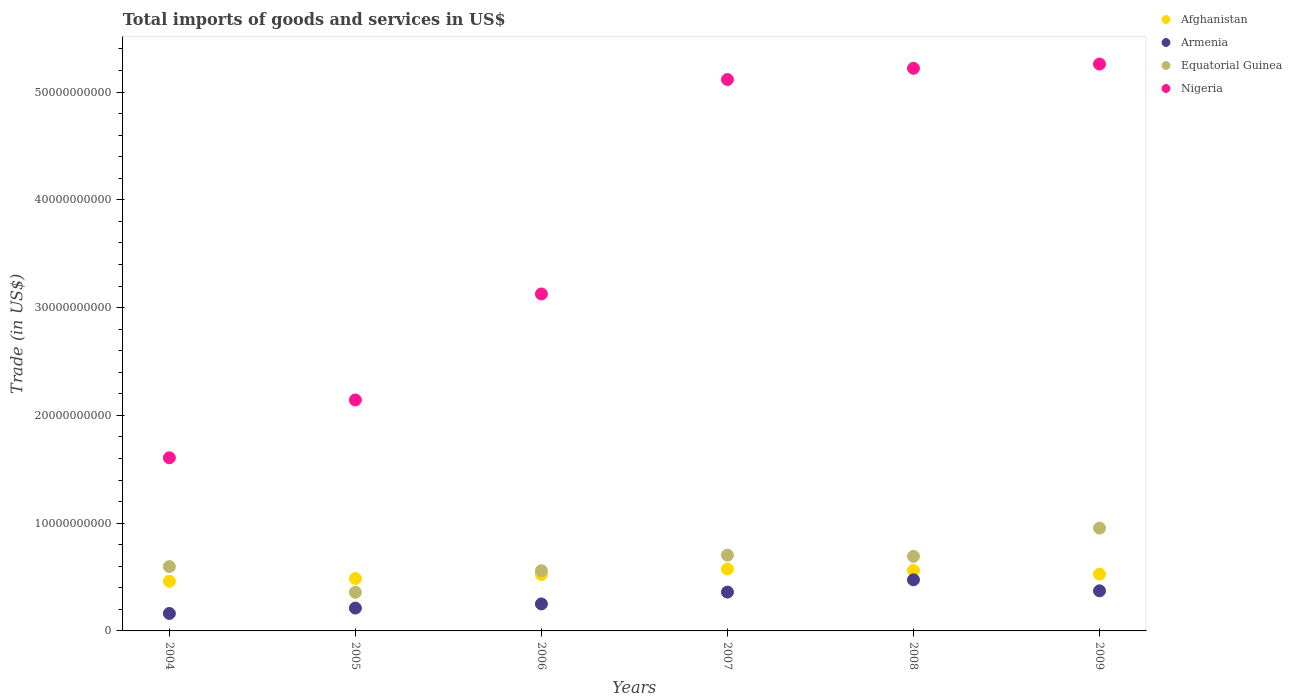What is the total imports of goods and services in Nigeria in 2004?
Make the answer very short. 1.61e+1. Across all years, what is the maximum total imports of goods and services in Armenia?
Provide a short and direct response. 4.74e+09. Across all years, what is the minimum total imports of goods and services in Equatorial Guinea?
Your response must be concise. 3.58e+09. In which year was the total imports of goods and services in Nigeria maximum?
Your answer should be compact. 2009. In which year was the total imports of goods and services in Afghanistan minimum?
Offer a very short reply. 2004. What is the total total imports of goods and services in Equatorial Guinea in the graph?
Your answer should be compact. 3.86e+1. What is the difference between the total imports of goods and services in Afghanistan in 2004 and that in 2007?
Your response must be concise. -1.14e+09. What is the difference between the total imports of goods and services in Equatorial Guinea in 2004 and the total imports of goods and services in Armenia in 2009?
Provide a succinct answer. 2.25e+09. What is the average total imports of goods and services in Armenia per year?
Ensure brevity in your answer.  3.05e+09. In the year 2005, what is the difference between the total imports of goods and services in Afghanistan and total imports of goods and services in Nigeria?
Provide a succinct answer. -1.66e+1. In how many years, is the total imports of goods and services in Nigeria greater than 18000000000 US$?
Your answer should be compact. 5. What is the ratio of the total imports of goods and services in Nigeria in 2006 to that in 2009?
Your answer should be very brief. 0.59. Is the difference between the total imports of goods and services in Afghanistan in 2007 and 2009 greater than the difference between the total imports of goods and services in Nigeria in 2007 and 2009?
Provide a succinct answer. Yes. What is the difference between the highest and the second highest total imports of goods and services in Afghanistan?
Offer a very short reply. 1.32e+08. What is the difference between the highest and the lowest total imports of goods and services in Nigeria?
Make the answer very short. 3.65e+1. In how many years, is the total imports of goods and services in Equatorial Guinea greater than the average total imports of goods and services in Equatorial Guinea taken over all years?
Keep it short and to the point. 3. Is it the case that in every year, the sum of the total imports of goods and services in Afghanistan and total imports of goods and services in Armenia  is greater than the sum of total imports of goods and services in Nigeria and total imports of goods and services in Equatorial Guinea?
Provide a succinct answer. No. Is it the case that in every year, the sum of the total imports of goods and services in Equatorial Guinea and total imports of goods and services in Nigeria  is greater than the total imports of goods and services in Afghanistan?
Keep it short and to the point. Yes. Is the total imports of goods and services in Equatorial Guinea strictly greater than the total imports of goods and services in Nigeria over the years?
Provide a short and direct response. No. Is the total imports of goods and services in Afghanistan strictly less than the total imports of goods and services in Nigeria over the years?
Keep it short and to the point. Yes. How many dotlines are there?
Provide a short and direct response. 4. Where does the legend appear in the graph?
Give a very brief answer. Top right. How are the legend labels stacked?
Give a very brief answer. Vertical. What is the title of the graph?
Your response must be concise. Total imports of goods and services in US$. Does "World" appear as one of the legend labels in the graph?
Offer a terse response. No. What is the label or title of the Y-axis?
Ensure brevity in your answer.  Trade (in US$). What is the Trade (in US$) in Afghanistan in 2004?
Your answer should be very brief. 4.61e+09. What is the Trade (in US$) in Armenia in 2004?
Give a very brief answer. 1.62e+09. What is the Trade (in US$) of Equatorial Guinea in 2004?
Give a very brief answer. 5.97e+09. What is the Trade (in US$) in Nigeria in 2004?
Give a very brief answer. 1.61e+1. What is the Trade (in US$) in Afghanistan in 2005?
Offer a very short reply. 4.86e+09. What is the Trade (in US$) in Armenia in 2005?
Your answer should be compact. 2.12e+09. What is the Trade (in US$) in Equatorial Guinea in 2005?
Your response must be concise. 3.58e+09. What is the Trade (in US$) of Nigeria in 2005?
Keep it short and to the point. 2.14e+1. What is the Trade (in US$) of Afghanistan in 2006?
Offer a terse response. 5.23e+09. What is the Trade (in US$) of Armenia in 2006?
Offer a very short reply. 2.51e+09. What is the Trade (in US$) of Equatorial Guinea in 2006?
Your response must be concise. 5.58e+09. What is the Trade (in US$) in Nigeria in 2006?
Offer a very short reply. 3.13e+1. What is the Trade (in US$) in Afghanistan in 2007?
Offer a terse response. 5.74e+09. What is the Trade (in US$) in Armenia in 2007?
Offer a very short reply. 3.60e+09. What is the Trade (in US$) in Equatorial Guinea in 2007?
Your response must be concise. 7.03e+09. What is the Trade (in US$) in Nigeria in 2007?
Give a very brief answer. 5.12e+1. What is the Trade (in US$) of Afghanistan in 2008?
Ensure brevity in your answer.  5.61e+09. What is the Trade (in US$) of Armenia in 2008?
Provide a succinct answer. 4.74e+09. What is the Trade (in US$) of Equatorial Guinea in 2008?
Keep it short and to the point. 6.92e+09. What is the Trade (in US$) of Nigeria in 2008?
Your response must be concise. 5.22e+1. What is the Trade (in US$) of Afghanistan in 2009?
Ensure brevity in your answer.  5.27e+09. What is the Trade (in US$) of Armenia in 2009?
Provide a short and direct response. 3.72e+09. What is the Trade (in US$) of Equatorial Guinea in 2009?
Your answer should be compact. 9.54e+09. What is the Trade (in US$) of Nigeria in 2009?
Your response must be concise. 5.26e+1. Across all years, what is the maximum Trade (in US$) of Afghanistan?
Offer a terse response. 5.74e+09. Across all years, what is the maximum Trade (in US$) of Armenia?
Your response must be concise. 4.74e+09. Across all years, what is the maximum Trade (in US$) in Equatorial Guinea?
Offer a terse response. 9.54e+09. Across all years, what is the maximum Trade (in US$) in Nigeria?
Provide a succinct answer. 5.26e+1. Across all years, what is the minimum Trade (in US$) in Afghanistan?
Offer a terse response. 4.61e+09. Across all years, what is the minimum Trade (in US$) of Armenia?
Keep it short and to the point. 1.62e+09. Across all years, what is the minimum Trade (in US$) in Equatorial Guinea?
Your answer should be very brief. 3.58e+09. Across all years, what is the minimum Trade (in US$) in Nigeria?
Provide a succinct answer. 1.61e+1. What is the total Trade (in US$) in Afghanistan in the graph?
Your answer should be compact. 3.13e+1. What is the total Trade (in US$) of Armenia in the graph?
Your answer should be very brief. 1.83e+1. What is the total Trade (in US$) in Equatorial Guinea in the graph?
Your answer should be compact. 3.86e+1. What is the total Trade (in US$) of Nigeria in the graph?
Give a very brief answer. 2.25e+11. What is the difference between the Trade (in US$) in Afghanistan in 2004 and that in 2005?
Your answer should be compact. -2.55e+08. What is the difference between the Trade (in US$) of Armenia in 2004 and that in 2005?
Offer a terse response. -4.98e+08. What is the difference between the Trade (in US$) of Equatorial Guinea in 2004 and that in 2005?
Make the answer very short. 2.39e+09. What is the difference between the Trade (in US$) of Nigeria in 2004 and that in 2005?
Make the answer very short. -5.37e+09. What is the difference between the Trade (in US$) of Afghanistan in 2004 and that in 2006?
Keep it short and to the point. -6.23e+08. What is the difference between the Trade (in US$) in Armenia in 2004 and that in 2006?
Your answer should be compact. -8.86e+08. What is the difference between the Trade (in US$) of Equatorial Guinea in 2004 and that in 2006?
Provide a succinct answer. 3.90e+08. What is the difference between the Trade (in US$) of Nigeria in 2004 and that in 2006?
Your answer should be compact. -1.52e+1. What is the difference between the Trade (in US$) of Afghanistan in 2004 and that in 2007?
Give a very brief answer. -1.14e+09. What is the difference between the Trade (in US$) of Armenia in 2004 and that in 2007?
Provide a short and direct response. -1.98e+09. What is the difference between the Trade (in US$) of Equatorial Guinea in 2004 and that in 2007?
Provide a succinct answer. -1.06e+09. What is the difference between the Trade (in US$) in Nigeria in 2004 and that in 2007?
Give a very brief answer. -3.51e+1. What is the difference between the Trade (in US$) of Afghanistan in 2004 and that in 2008?
Make the answer very short. -1.01e+09. What is the difference between the Trade (in US$) in Armenia in 2004 and that in 2008?
Your answer should be compact. -3.12e+09. What is the difference between the Trade (in US$) in Equatorial Guinea in 2004 and that in 2008?
Provide a succinct answer. -9.47e+08. What is the difference between the Trade (in US$) of Nigeria in 2004 and that in 2008?
Give a very brief answer. -3.61e+1. What is the difference between the Trade (in US$) in Afghanistan in 2004 and that in 2009?
Give a very brief answer. -6.64e+08. What is the difference between the Trade (in US$) in Armenia in 2004 and that in 2009?
Your answer should be very brief. -2.10e+09. What is the difference between the Trade (in US$) in Equatorial Guinea in 2004 and that in 2009?
Provide a succinct answer. -3.57e+09. What is the difference between the Trade (in US$) of Nigeria in 2004 and that in 2009?
Ensure brevity in your answer.  -3.65e+1. What is the difference between the Trade (in US$) in Afghanistan in 2005 and that in 2006?
Offer a very short reply. -3.68e+08. What is the difference between the Trade (in US$) in Armenia in 2005 and that in 2006?
Give a very brief answer. -3.87e+08. What is the difference between the Trade (in US$) in Equatorial Guinea in 2005 and that in 2006?
Provide a short and direct response. -2.00e+09. What is the difference between the Trade (in US$) of Nigeria in 2005 and that in 2006?
Ensure brevity in your answer.  -9.83e+09. What is the difference between the Trade (in US$) in Afghanistan in 2005 and that in 2007?
Give a very brief answer. -8.83e+08. What is the difference between the Trade (in US$) in Armenia in 2005 and that in 2007?
Give a very brief answer. -1.49e+09. What is the difference between the Trade (in US$) of Equatorial Guinea in 2005 and that in 2007?
Make the answer very short. -3.45e+09. What is the difference between the Trade (in US$) of Nigeria in 2005 and that in 2007?
Make the answer very short. -2.97e+1. What is the difference between the Trade (in US$) in Afghanistan in 2005 and that in 2008?
Your answer should be very brief. -7.51e+08. What is the difference between the Trade (in US$) in Armenia in 2005 and that in 2008?
Keep it short and to the point. -2.62e+09. What is the difference between the Trade (in US$) of Equatorial Guinea in 2005 and that in 2008?
Make the answer very short. -3.34e+09. What is the difference between the Trade (in US$) in Nigeria in 2005 and that in 2008?
Offer a terse response. -3.08e+1. What is the difference between the Trade (in US$) in Afghanistan in 2005 and that in 2009?
Make the answer very short. -4.08e+08. What is the difference between the Trade (in US$) in Armenia in 2005 and that in 2009?
Give a very brief answer. -1.60e+09. What is the difference between the Trade (in US$) of Equatorial Guinea in 2005 and that in 2009?
Provide a short and direct response. -5.96e+09. What is the difference between the Trade (in US$) of Nigeria in 2005 and that in 2009?
Offer a terse response. -3.12e+1. What is the difference between the Trade (in US$) in Afghanistan in 2006 and that in 2007?
Your answer should be compact. -5.15e+08. What is the difference between the Trade (in US$) in Armenia in 2006 and that in 2007?
Offer a very short reply. -1.10e+09. What is the difference between the Trade (in US$) of Equatorial Guinea in 2006 and that in 2007?
Offer a terse response. -1.45e+09. What is the difference between the Trade (in US$) in Nigeria in 2006 and that in 2007?
Keep it short and to the point. -1.99e+1. What is the difference between the Trade (in US$) in Afghanistan in 2006 and that in 2008?
Offer a very short reply. -3.84e+08. What is the difference between the Trade (in US$) in Armenia in 2006 and that in 2008?
Your answer should be compact. -2.24e+09. What is the difference between the Trade (in US$) in Equatorial Guinea in 2006 and that in 2008?
Offer a very short reply. -1.34e+09. What is the difference between the Trade (in US$) of Nigeria in 2006 and that in 2008?
Offer a terse response. -2.09e+1. What is the difference between the Trade (in US$) of Afghanistan in 2006 and that in 2009?
Keep it short and to the point. -4.08e+07. What is the difference between the Trade (in US$) in Armenia in 2006 and that in 2009?
Keep it short and to the point. -1.21e+09. What is the difference between the Trade (in US$) in Equatorial Guinea in 2006 and that in 2009?
Provide a short and direct response. -3.96e+09. What is the difference between the Trade (in US$) in Nigeria in 2006 and that in 2009?
Provide a succinct answer. -2.13e+1. What is the difference between the Trade (in US$) of Afghanistan in 2007 and that in 2008?
Your answer should be very brief. 1.32e+08. What is the difference between the Trade (in US$) in Armenia in 2007 and that in 2008?
Keep it short and to the point. -1.14e+09. What is the difference between the Trade (in US$) in Equatorial Guinea in 2007 and that in 2008?
Make the answer very short. 1.16e+08. What is the difference between the Trade (in US$) in Nigeria in 2007 and that in 2008?
Your answer should be very brief. -1.05e+09. What is the difference between the Trade (in US$) in Afghanistan in 2007 and that in 2009?
Keep it short and to the point. 4.74e+08. What is the difference between the Trade (in US$) in Armenia in 2007 and that in 2009?
Provide a succinct answer. -1.15e+08. What is the difference between the Trade (in US$) of Equatorial Guinea in 2007 and that in 2009?
Ensure brevity in your answer.  -2.51e+09. What is the difference between the Trade (in US$) of Nigeria in 2007 and that in 2009?
Give a very brief answer. -1.44e+09. What is the difference between the Trade (in US$) of Afghanistan in 2008 and that in 2009?
Make the answer very short. 3.43e+08. What is the difference between the Trade (in US$) in Armenia in 2008 and that in 2009?
Make the answer very short. 1.02e+09. What is the difference between the Trade (in US$) of Equatorial Guinea in 2008 and that in 2009?
Offer a terse response. -2.62e+09. What is the difference between the Trade (in US$) in Nigeria in 2008 and that in 2009?
Keep it short and to the point. -3.94e+08. What is the difference between the Trade (in US$) of Afghanistan in 2004 and the Trade (in US$) of Armenia in 2005?
Your answer should be very brief. 2.49e+09. What is the difference between the Trade (in US$) of Afghanistan in 2004 and the Trade (in US$) of Equatorial Guinea in 2005?
Provide a short and direct response. 1.02e+09. What is the difference between the Trade (in US$) of Afghanistan in 2004 and the Trade (in US$) of Nigeria in 2005?
Offer a very short reply. -1.68e+1. What is the difference between the Trade (in US$) in Armenia in 2004 and the Trade (in US$) in Equatorial Guinea in 2005?
Ensure brevity in your answer.  -1.96e+09. What is the difference between the Trade (in US$) of Armenia in 2004 and the Trade (in US$) of Nigeria in 2005?
Provide a succinct answer. -1.98e+1. What is the difference between the Trade (in US$) of Equatorial Guinea in 2004 and the Trade (in US$) of Nigeria in 2005?
Provide a succinct answer. -1.55e+1. What is the difference between the Trade (in US$) of Afghanistan in 2004 and the Trade (in US$) of Armenia in 2006?
Keep it short and to the point. 2.10e+09. What is the difference between the Trade (in US$) of Afghanistan in 2004 and the Trade (in US$) of Equatorial Guinea in 2006?
Give a very brief answer. -9.76e+08. What is the difference between the Trade (in US$) in Afghanistan in 2004 and the Trade (in US$) in Nigeria in 2006?
Offer a terse response. -2.67e+1. What is the difference between the Trade (in US$) in Armenia in 2004 and the Trade (in US$) in Equatorial Guinea in 2006?
Offer a terse response. -3.96e+09. What is the difference between the Trade (in US$) of Armenia in 2004 and the Trade (in US$) of Nigeria in 2006?
Your answer should be very brief. -2.96e+1. What is the difference between the Trade (in US$) of Equatorial Guinea in 2004 and the Trade (in US$) of Nigeria in 2006?
Make the answer very short. -2.53e+1. What is the difference between the Trade (in US$) of Afghanistan in 2004 and the Trade (in US$) of Armenia in 2007?
Ensure brevity in your answer.  1.00e+09. What is the difference between the Trade (in US$) in Afghanistan in 2004 and the Trade (in US$) in Equatorial Guinea in 2007?
Ensure brevity in your answer.  -2.43e+09. What is the difference between the Trade (in US$) in Afghanistan in 2004 and the Trade (in US$) in Nigeria in 2007?
Your answer should be compact. -4.66e+1. What is the difference between the Trade (in US$) in Armenia in 2004 and the Trade (in US$) in Equatorial Guinea in 2007?
Give a very brief answer. -5.41e+09. What is the difference between the Trade (in US$) in Armenia in 2004 and the Trade (in US$) in Nigeria in 2007?
Give a very brief answer. -4.95e+1. What is the difference between the Trade (in US$) of Equatorial Guinea in 2004 and the Trade (in US$) of Nigeria in 2007?
Offer a terse response. -4.52e+1. What is the difference between the Trade (in US$) in Afghanistan in 2004 and the Trade (in US$) in Armenia in 2008?
Provide a short and direct response. -1.36e+08. What is the difference between the Trade (in US$) of Afghanistan in 2004 and the Trade (in US$) of Equatorial Guinea in 2008?
Give a very brief answer. -2.31e+09. What is the difference between the Trade (in US$) in Afghanistan in 2004 and the Trade (in US$) in Nigeria in 2008?
Offer a very short reply. -4.76e+1. What is the difference between the Trade (in US$) in Armenia in 2004 and the Trade (in US$) in Equatorial Guinea in 2008?
Your response must be concise. -5.30e+09. What is the difference between the Trade (in US$) in Armenia in 2004 and the Trade (in US$) in Nigeria in 2008?
Provide a succinct answer. -5.06e+1. What is the difference between the Trade (in US$) of Equatorial Guinea in 2004 and the Trade (in US$) of Nigeria in 2008?
Offer a very short reply. -4.62e+1. What is the difference between the Trade (in US$) of Afghanistan in 2004 and the Trade (in US$) of Armenia in 2009?
Provide a succinct answer. 8.87e+08. What is the difference between the Trade (in US$) in Afghanistan in 2004 and the Trade (in US$) in Equatorial Guinea in 2009?
Your response must be concise. -4.93e+09. What is the difference between the Trade (in US$) of Afghanistan in 2004 and the Trade (in US$) of Nigeria in 2009?
Keep it short and to the point. -4.80e+1. What is the difference between the Trade (in US$) of Armenia in 2004 and the Trade (in US$) of Equatorial Guinea in 2009?
Your answer should be very brief. -7.92e+09. What is the difference between the Trade (in US$) of Armenia in 2004 and the Trade (in US$) of Nigeria in 2009?
Keep it short and to the point. -5.10e+1. What is the difference between the Trade (in US$) in Equatorial Guinea in 2004 and the Trade (in US$) in Nigeria in 2009?
Keep it short and to the point. -4.66e+1. What is the difference between the Trade (in US$) in Afghanistan in 2005 and the Trade (in US$) in Armenia in 2006?
Keep it short and to the point. 2.36e+09. What is the difference between the Trade (in US$) in Afghanistan in 2005 and the Trade (in US$) in Equatorial Guinea in 2006?
Your answer should be very brief. -7.20e+08. What is the difference between the Trade (in US$) of Afghanistan in 2005 and the Trade (in US$) of Nigeria in 2006?
Give a very brief answer. -2.64e+1. What is the difference between the Trade (in US$) of Armenia in 2005 and the Trade (in US$) of Equatorial Guinea in 2006?
Offer a terse response. -3.46e+09. What is the difference between the Trade (in US$) in Armenia in 2005 and the Trade (in US$) in Nigeria in 2006?
Your answer should be very brief. -2.91e+1. What is the difference between the Trade (in US$) in Equatorial Guinea in 2005 and the Trade (in US$) in Nigeria in 2006?
Provide a short and direct response. -2.77e+1. What is the difference between the Trade (in US$) of Afghanistan in 2005 and the Trade (in US$) of Armenia in 2007?
Your answer should be compact. 1.26e+09. What is the difference between the Trade (in US$) in Afghanistan in 2005 and the Trade (in US$) in Equatorial Guinea in 2007?
Your answer should be very brief. -2.17e+09. What is the difference between the Trade (in US$) in Afghanistan in 2005 and the Trade (in US$) in Nigeria in 2007?
Offer a terse response. -4.63e+1. What is the difference between the Trade (in US$) in Armenia in 2005 and the Trade (in US$) in Equatorial Guinea in 2007?
Provide a succinct answer. -4.92e+09. What is the difference between the Trade (in US$) of Armenia in 2005 and the Trade (in US$) of Nigeria in 2007?
Ensure brevity in your answer.  -4.90e+1. What is the difference between the Trade (in US$) of Equatorial Guinea in 2005 and the Trade (in US$) of Nigeria in 2007?
Ensure brevity in your answer.  -4.76e+1. What is the difference between the Trade (in US$) of Afghanistan in 2005 and the Trade (in US$) of Armenia in 2008?
Provide a short and direct response. 1.20e+08. What is the difference between the Trade (in US$) of Afghanistan in 2005 and the Trade (in US$) of Equatorial Guinea in 2008?
Give a very brief answer. -2.06e+09. What is the difference between the Trade (in US$) of Afghanistan in 2005 and the Trade (in US$) of Nigeria in 2008?
Your answer should be compact. -4.73e+1. What is the difference between the Trade (in US$) of Armenia in 2005 and the Trade (in US$) of Equatorial Guinea in 2008?
Provide a succinct answer. -4.80e+09. What is the difference between the Trade (in US$) in Armenia in 2005 and the Trade (in US$) in Nigeria in 2008?
Make the answer very short. -5.01e+1. What is the difference between the Trade (in US$) in Equatorial Guinea in 2005 and the Trade (in US$) in Nigeria in 2008?
Offer a terse response. -4.86e+1. What is the difference between the Trade (in US$) in Afghanistan in 2005 and the Trade (in US$) in Armenia in 2009?
Ensure brevity in your answer.  1.14e+09. What is the difference between the Trade (in US$) in Afghanistan in 2005 and the Trade (in US$) in Equatorial Guinea in 2009?
Your answer should be compact. -4.68e+09. What is the difference between the Trade (in US$) in Afghanistan in 2005 and the Trade (in US$) in Nigeria in 2009?
Provide a short and direct response. -4.77e+1. What is the difference between the Trade (in US$) of Armenia in 2005 and the Trade (in US$) of Equatorial Guinea in 2009?
Make the answer very short. -7.42e+09. What is the difference between the Trade (in US$) of Armenia in 2005 and the Trade (in US$) of Nigeria in 2009?
Provide a succinct answer. -5.05e+1. What is the difference between the Trade (in US$) in Equatorial Guinea in 2005 and the Trade (in US$) in Nigeria in 2009?
Give a very brief answer. -4.90e+1. What is the difference between the Trade (in US$) in Afghanistan in 2006 and the Trade (in US$) in Armenia in 2007?
Provide a short and direct response. 1.62e+09. What is the difference between the Trade (in US$) in Afghanistan in 2006 and the Trade (in US$) in Equatorial Guinea in 2007?
Your answer should be compact. -1.81e+09. What is the difference between the Trade (in US$) in Afghanistan in 2006 and the Trade (in US$) in Nigeria in 2007?
Make the answer very short. -4.59e+1. What is the difference between the Trade (in US$) of Armenia in 2006 and the Trade (in US$) of Equatorial Guinea in 2007?
Provide a succinct answer. -4.53e+09. What is the difference between the Trade (in US$) in Armenia in 2006 and the Trade (in US$) in Nigeria in 2007?
Provide a succinct answer. -4.87e+1. What is the difference between the Trade (in US$) in Equatorial Guinea in 2006 and the Trade (in US$) in Nigeria in 2007?
Your response must be concise. -4.56e+1. What is the difference between the Trade (in US$) of Afghanistan in 2006 and the Trade (in US$) of Armenia in 2008?
Make the answer very short. 4.87e+08. What is the difference between the Trade (in US$) of Afghanistan in 2006 and the Trade (in US$) of Equatorial Guinea in 2008?
Make the answer very short. -1.69e+09. What is the difference between the Trade (in US$) in Afghanistan in 2006 and the Trade (in US$) in Nigeria in 2008?
Ensure brevity in your answer.  -4.70e+1. What is the difference between the Trade (in US$) of Armenia in 2006 and the Trade (in US$) of Equatorial Guinea in 2008?
Give a very brief answer. -4.41e+09. What is the difference between the Trade (in US$) in Armenia in 2006 and the Trade (in US$) in Nigeria in 2008?
Keep it short and to the point. -4.97e+1. What is the difference between the Trade (in US$) of Equatorial Guinea in 2006 and the Trade (in US$) of Nigeria in 2008?
Keep it short and to the point. -4.66e+1. What is the difference between the Trade (in US$) of Afghanistan in 2006 and the Trade (in US$) of Armenia in 2009?
Your response must be concise. 1.51e+09. What is the difference between the Trade (in US$) in Afghanistan in 2006 and the Trade (in US$) in Equatorial Guinea in 2009?
Your answer should be very brief. -4.31e+09. What is the difference between the Trade (in US$) of Afghanistan in 2006 and the Trade (in US$) of Nigeria in 2009?
Offer a very short reply. -4.74e+1. What is the difference between the Trade (in US$) in Armenia in 2006 and the Trade (in US$) in Equatorial Guinea in 2009?
Your answer should be compact. -7.03e+09. What is the difference between the Trade (in US$) in Armenia in 2006 and the Trade (in US$) in Nigeria in 2009?
Provide a succinct answer. -5.01e+1. What is the difference between the Trade (in US$) of Equatorial Guinea in 2006 and the Trade (in US$) of Nigeria in 2009?
Keep it short and to the point. -4.70e+1. What is the difference between the Trade (in US$) in Afghanistan in 2007 and the Trade (in US$) in Armenia in 2008?
Offer a terse response. 1.00e+09. What is the difference between the Trade (in US$) of Afghanistan in 2007 and the Trade (in US$) of Equatorial Guinea in 2008?
Your answer should be compact. -1.17e+09. What is the difference between the Trade (in US$) of Afghanistan in 2007 and the Trade (in US$) of Nigeria in 2008?
Ensure brevity in your answer.  -4.65e+1. What is the difference between the Trade (in US$) in Armenia in 2007 and the Trade (in US$) in Equatorial Guinea in 2008?
Your answer should be compact. -3.31e+09. What is the difference between the Trade (in US$) in Armenia in 2007 and the Trade (in US$) in Nigeria in 2008?
Offer a terse response. -4.86e+1. What is the difference between the Trade (in US$) of Equatorial Guinea in 2007 and the Trade (in US$) of Nigeria in 2008?
Provide a short and direct response. -4.52e+1. What is the difference between the Trade (in US$) in Afghanistan in 2007 and the Trade (in US$) in Armenia in 2009?
Offer a very short reply. 2.02e+09. What is the difference between the Trade (in US$) in Afghanistan in 2007 and the Trade (in US$) in Equatorial Guinea in 2009?
Keep it short and to the point. -3.80e+09. What is the difference between the Trade (in US$) of Afghanistan in 2007 and the Trade (in US$) of Nigeria in 2009?
Keep it short and to the point. -4.69e+1. What is the difference between the Trade (in US$) in Armenia in 2007 and the Trade (in US$) in Equatorial Guinea in 2009?
Your response must be concise. -5.94e+09. What is the difference between the Trade (in US$) of Armenia in 2007 and the Trade (in US$) of Nigeria in 2009?
Ensure brevity in your answer.  -4.90e+1. What is the difference between the Trade (in US$) of Equatorial Guinea in 2007 and the Trade (in US$) of Nigeria in 2009?
Provide a succinct answer. -4.56e+1. What is the difference between the Trade (in US$) of Afghanistan in 2008 and the Trade (in US$) of Armenia in 2009?
Offer a very short reply. 1.89e+09. What is the difference between the Trade (in US$) in Afghanistan in 2008 and the Trade (in US$) in Equatorial Guinea in 2009?
Give a very brief answer. -3.93e+09. What is the difference between the Trade (in US$) of Afghanistan in 2008 and the Trade (in US$) of Nigeria in 2009?
Keep it short and to the point. -4.70e+1. What is the difference between the Trade (in US$) in Armenia in 2008 and the Trade (in US$) in Equatorial Guinea in 2009?
Your response must be concise. -4.80e+09. What is the difference between the Trade (in US$) of Armenia in 2008 and the Trade (in US$) of Nigeria in 2009?
Your response must be concise. -4.79e+1. What is the difference between the Trade (in US$) of Equatorial Guinea in 2008 and the Trade (in US$) of Nigeria in 2009?
Offer a terse response. -4.57e+1. What is the average Trade (in US$) in Afghanistan per year?
Make the answer very short. 5.22e+09. What is the average Trade (in US$) of Armenia per year?
Make the answer very short. 3.05e+09. What is the average Trade (in US$) in Equatorial Guinea per year?
Offer a terse response. 6.44e+09. What is the average Trade (in US$) of Nigeria per year?
Provide a succinct answer. 3.75e+1. In the year 2004, what is the difference between the Trade (in US$) of Afghanistan and Trade (in US$) of Armenia?
Provide a short and direct response. 2.99e+09. In the year 2004, what is the difference between the Trade (in US$) in Afghanistan and Trade (in US$) in Equatorial Guinea?
Provide a short and direct response. -1.37e+09. In the year 2004, what is the difference between the Trade (in US$) of Afghanistan and Trade (in US$) of Nigeria?
Provide a succinct answer. -1.15e+1. In the year 2004, what is the difference between the Trade (in US$) of Armenia and Trade (in US$) of Equatorial Guinea?
Offer a very short reply. -4.35e+09. In the year 2004, what is the difference between the Trade (in US$) in Armenia and Trade (in US$) in Nigeria?
Provide a short and direct response. -1.44e+1. In the year 2004, what is the difference between the Trade (in US$) of Equatorial Guinea and Trade (in US$) of Nigeria?
Offer a very short reply. -1.01e+1. In the year 2005, what is the difference between the Trade (in US$) of Afghanistan and Trade (in US$) of Armenia?
Keep it short and to the point. 2.74e+09. In the year 2005, what is the difference between the Trade (in US$) of Afghanistan and Trade (in US$) of Equatorial Guinea?
Provide a short and direct response. 1.28e+09. In the year 2005, what is the difference between the Trade (in US$) of Afghanistan and Trade (in US$) of Nigeria?
Your response must be concise. -1.66e+1. In the year 2005, what is the difference between the Trade (in US$) of Armenia and Trade (in US$) of Equatorial Guinea?
Your answer should be very brief. -1.46e+09. In the year 2005, what is the difference between the Trade (in US$) in Armenia and Trade (in US$) in Nigeria?
Your answer should be very brief. -1.93e+1. In the year 2005, what is the difference between the Trade (in US$) of Equatorial Guinea and Trade (in US$) of Nigeria?
Provide a succinct answer. -1.78e+1. In the year 2006, what is the difference between the Trade (in US$) in Afghanistan and Trade (in US$) in Armenia?
Offer a very short reply. 2.72e+09. In the year 2006, what is the difference between the Trade (in US$) of Afghanistan and Trade (in US$) of Equatorial Guinea?
Offer a very short reply. -3.53e+08. In the year 2006, what is the difference between the Trade (in US$) in Afghanistan and Trade (in US$) in Nigeria?
Make the answer very short. -2.60e+1. In the year 2006, what is the difference between the Trade (in US$) of Armenia and Trade (in US$) of Equatorial Guinea?
Your response must be concise. -3.08e+09. In the year 2006, what is the difference between the Trade (in US$) in Armenia and Trade (in US$) in Nigeria?
Make the answer very short. -2.88e+1. In the year 2006, what is the difference between the Trade (in US$) of Equatorial Guinea and Trade (in US$) of Nigeria?
Give a very brief answer. -2.57e+1. In the year 2007, what is the difference between the Trade (in US$) in Afghanistan and Trade (in US$) in Armenia?
Provide a short and direct response. 2.14e+09. In the year 2007, what is the difference between the Trade (in US$) in Afghanistan and Trade (in US$) in Equatorial Guinea?
Provide a short and direct response. -1.29e+09. In the year 2007, what is the difference between the Trade (in US$) in Afghanistan and Trade (in US$) in Nigeria?
Give a very brief answer. -4.54e+1. In the year 2007, what is the difference between the Trade (in US$) in Armenia and Trade (in US$) in Equatorial Guinea?
Offer a very short reply. -3.43e+09. In the year 2007, what is the difference between the Trade (in US$) in Armenia and Trade (in US$) in Nigeria?
Keep it short and to the point. -4.76e+1. In the year 2007, what is the difference between the Trade (in US$) of Equatorial Guinea and Trade (in US$) of Nigeria?
Provide a succinct answer. -4.41e+1. In the year 2008, what is the difference between the Trade (in US$) of Afghanistan and Trade (in US$) of Armenia?
Provide a short and direct response. 8.71e+08. In the year 2008, what is the difference between the Trade (in US$) in Afghanistan and Trade (in US$) in Equatorial Guinea?
Make the answer very short. -1.31e+09. In the year 2008, what is the difference between the Trade (in US$) in Afghanistan and Trade (in US$) in Nigeria?
Provide a succinct answer. -4.66e+1. In the year 2008, what is the difference between the Trade (in US$) of Armenia and Trade (in US$) of Equatorial Guinea?
Make the answer very short. -2.18e+09. In the year 2008, what is the difference between the Trade (in US$) in Armenia and Trade (in US$) in Nigeria?
Ensure brevity in your answer.  -4.75e+1. In the year 2008, what is the difference between the Trade (in US$) of Equatorial Guinea and Trade (in US$) of Nigeria?
Offer a terse response. -4.53e+1. In the year 2009, what is the difference between the Trade (in US$) of Afghanistan and Trade (in US$) of Armenia?
Your response must be concise. 1.55e+09. In the year 2009, what is the difference between the Trade (in US$) in Afghanistan and Trade (in US$) in Equatorial Guinea?
Your answer should be very brief. -4.27e+09. In the year 2009, what is the difference between the Trade (in US$) of Afghanistan and Trade (in US$) of Nigeria?
Provide a short and direct response. -4.73e+1. In the year 2009, what is the difference between the Trade (in US$) in Armenia and Trade (in US$) in Equatorial Guinea?
Provide a succinct answer. -5.82e+09. In the year 2009, what is the difference between the Trade (in US$) in Armenia and Trade (in US$) in Nigeria?
Give a very brief answer. -4.89e+1. In the year 2009, what is the difference between the Trade (in US$) in Equatorial Guinea and Trade (in US$) in Nigeria?
Provide a succinct answer. -4.31e+1. What is the ratio of the Trade (in US$) of Afghanistan in 2004 to that in 2005?
Provide a short and direct response. 0.95. What is the ratio of the Trade (in US$) of Armenia in 2004 to that in 2005?
Your answer should be compact. 0.76. What is the ratio of the Trade (in US$) in Equatorial Guinea in 2004 to that in 2005?
Your response must be concise. 1.67. What is the ratio of the Trade (in US$) in Nigeria in 2004 to that in 2005?
Offer a very short reply. 0.75. What is the ratio of the Trade (in US$) of Afghanistan in 2004 to that in 2006?
Ensure brevity in your answer.  0.88. What is the ratio of the Trade (in US$) in Armenia in 2004 to that in 2006?
Provide a short and direct response. 0.65. What is the ratio of the Trade (in US$) of Equatorial Guinea in 2004 to that in 2006?
Your answer should be compact. 1.07. What is the ratio of the Trade (in US$) of Nigeria in 2004 to that in 2006?
Provide a short and direct response. 0.51. What is the ratio of the Trade (in US$) in Afghanistan in 2004 to that in 2007?
Keep it short and to the point. 0.8. What is the ratio of the Trade (in US$) of Armenia in 2004 to that in 2007?
Your answer should be compact. 0.45. What is the ratio of the Trade (in US$) of Equatorial Guinea in 2004 to that in 2007?
Offer a very short reply. 0.85. What is the ratio of the Trade (in US$) of Nigeria in 2004 to that in 2007?
Offer a very short reply. 0.31. What is the ratio of the Trade (in US$) of Afghanistan in 2004 to that in 2008?
Your response must be concise. 0.82. What is the ratio of the Trade (in US$) of Armenia in 2004 to that in 2008?
Your answer should be compact. 0.34. What is the ratio of the Trade (in US$) of Equatorial Guinea in 2004 to that in 2008?
Ensure brevity in your answer.  0.86. What is the ratio of the Trade (in US$) of Nigeria in 2004 to that in 2008?
Give a very brief answer. 0.31. What is the ratio of the Trade (in US$) in Afghanistan in 2004 to that in 2009?
Your answer should be compact. 0.87. What is the ratio of the Trade (in US$) of Armenia in 2004 to that in 2009?
Your answer should be very brief. 0.44. What is the ratio of the Trade (in US$) in Equatorial Guinea in 2004 to that in 2009?
Offer a terse response. 0.63. What is the ratio of the Trade (in US$) of Nigeria in 2004 to that in 2009?
Your answer should be compact. 0.31. What is the ratio of the Trade (in US$) in Afghanistan in 2005 to that in 2006?
Ensure brevity in your answer.  0.93. What is the ratio of the Trade (in US$) in Armenia in 2005 to that in 2006?
Provide a short and direct response. 0.85. What is the ratio of the Trade (in US$) of Equatorial Guinea in 2005 to that in 2006?
Provide a succinct answer. 0.64. What is the ratio of the Trade (in US$) in Nigeria in 2005 to that in 2006?
Your answer should be very brief. 0.69. What is the ratio of the Trade (in US$) in Afghanistan in 2005 to that in 2007?
Offer a terse response. 0.85. What is the ratio of the Trade (in US$) of Armenia in 2005 to that in 2007?
Give a very brief answer. 0.59. What is the ratio of the Trade (in US$) of Equatorial Guinea in 2005 to that in 2007?
Give a very brief answer. 0.51. What is the ratio of the Trade (in US$) in Nigeria in 2005 to that in 2007?
Your answer should be very brief. 0.42. What is the ratio of the Trade (in US$) of Afghanistan in 2005 to that in 2008?
Your answer should be compact. 0.87. What is the ratio of the Trade (in US$) of Armenia in 2005 to that in 2008?
Offer a terse response. 0.45. What is the ratio of the Trade (in US$) of Equatorial Guinea in 2005 to that in 2008?
Offer a terse response. 0.52. What is the ratio of the Trade (in US$) of Nigeria in 2005 to that in 2008?
Your answer should be compact. 0.41. What is the ratio of the Trade (in US$) in Afghanistan in 2005 to that in 2009?
Keep it short and to the point. 0.92. What is the ratio of the Trade (in US$) of Armenia in 2005 to that in 2009?
Ensure brevity in your answer.  0.57. What is the ratio of the Trade (in US$) of Equatorial Guinea in 2005 to that in 2009?
Keep it short and to the point. 0.38. What is the ratio of the Trade (in US$) of Nigeria in 2005 to that in 2009?
Keep it short and to the point. 0.41. What is the ratio of the Trade (in US$) in Afghanistan in 2006 to that in 2007?
Your response must be concise. 0.91. What is the ratio of the Trade (in US$) in Armenia in 2006 to that in 2007?
Keep it short and to the point. 0.7. What is the ratio of the Trade (in US$) in Equatorial Guinea in 2006 to that in 2007?
Keep it short and to the point. 0.79. What is the ratio of the Trade (in US$) of Nigeria in 2006 to that in 2007?
Your answer should be very brief. 0.61. What is the ratio of the Trade (in US$) of Afghanistan in 2006 to that in 2008?
Provide a succinct answer. 0.93. What is the ratio of the Trade (in US$) of Armenia in 2006 to that in 2008?
Your response must be concise. 0.53. What is the ratio of the Trade (in US$) in Equatorial Guinea in 2006 to that in 2008?
Your answer should be compact. 0.81. What is the ratio of the Trade (in US$) of Nigeria in 2006 to that in 2008?
Your answer should be very brief. 0.6. What is the ratio of the Trade (in US$) of Afghanistan in 2006 to that in 2009?
Make the answer very short. 0.99. What is the ratio of the Trade (in US$) of Armenia in 2006 to that in 2009?
Your answer should be compact. 0.67. What is the ratio of the Trade (in US$) in Equatorial Guinea in 2006 to that in 2009?
Ensure brevity in your answer.  0.59. What is the ratio of the Trade (in US$) of Nigeria in 2006 to that in 2009?
Your answer should be compact. 0.59. What is the ratio of the Trade (in US$) of Afghanistan in 2007 to that in 2008?
Ensure brevity in your answer.  1.02. What is the ratio of the Trade (in US$) in Armenia in 2007 to that in 2008?
Offer a terse response. 0.76. What is the ratio of the Trade (in US$) of Equatorial Guinea in 2007 to that in 2008?
Provide a short and direct response. 1.02. What is the ratio of the Trade (in US$) of Nigeria in 2007 to that in 2008?
Provide a succinct answer. 0.98. What is the ratio of the Trade (in US$) in Afghanistan in 2007 to that in 2009?
Your answer should be compact. 1.09. What is the ratio of the Trade (in US$) in Armenia in 2007 to that in 2009?
Offer a very short reply. 0.97. What is the ratio of the Trade (in US$) in Equatorial Guinea in 2007 to that in 2009?
Provide a succinct answer. 0.74. What is the ratio of the Trade (in US$) in Nigeria in 2007 to that in 2009?
Give a very brief answer. 0.97. What is the ratio of the Trade (in US$) in Afghanistan in 2008 to that in 2009?
Your answer should be very brief. 1.07. What is the ratio of the Trade (in US$) of Armenia in 2008 to that in 2009?
Give a very brief answer. 1.27. What is the ratio of the Trade (in US$) in Equatorial Guinea in 2008 to that in 2009?
Offer a terse response. 0.73. What is the difference between the highest and the second highest Trade (in US$) of Afghanistan?
Offer a very short reply. 1.32e+08. What is the difference between the highest and the second highest Trade (in US$) of Armenia?
Make the answer very short. 1.02e+09. What is the difference between the highest and the second highest Trade (in US$) of Equatorial Guinea?
Your answer should be very brief. 2.51e+09. What is the difference between the highest and the second highest Trade (in US$) in Nigeria?
Provide a succinct answer. 3.94e+08. What is the difference between the highest and the lowest Trade (in US$) in Afghanistan?
Give a very brief answer. 1.14e+09. What is the difference between the highest and the lowest Trade (in US$) of Armenia?
Make the answer very short. 3.12e+09. What is the difference between the highest and the lowest Trade (in US$) in Equatorial Guinea?
Your answer should be compact. 5.96e+09. What is the difference between the highest and the lowest Trade (in US$) of Nigeria?
Offer a terse response. 3.65e+1. 